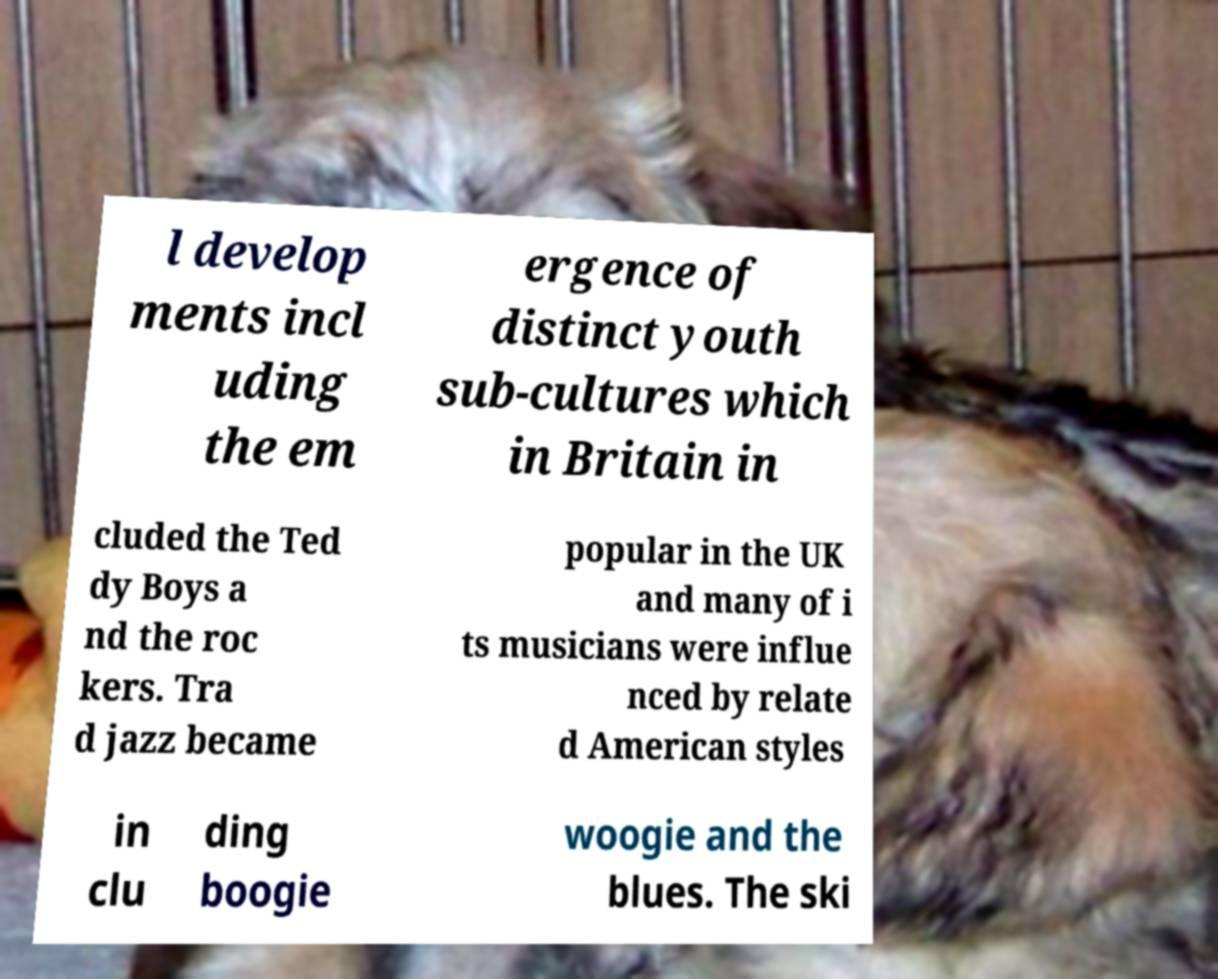Could you assist in decoding the text presented in this image and type it out clearly? l develop ments incl uding the em ergence of distinct youth sub-cultures which in Britain in cluded the Ted dy Boys a nd the roc kers. Tra d jazz became popular in the UK and many of i ts musicians were influe nced by relate d American styles in clu ding boogie woogie and the blues. The ski 